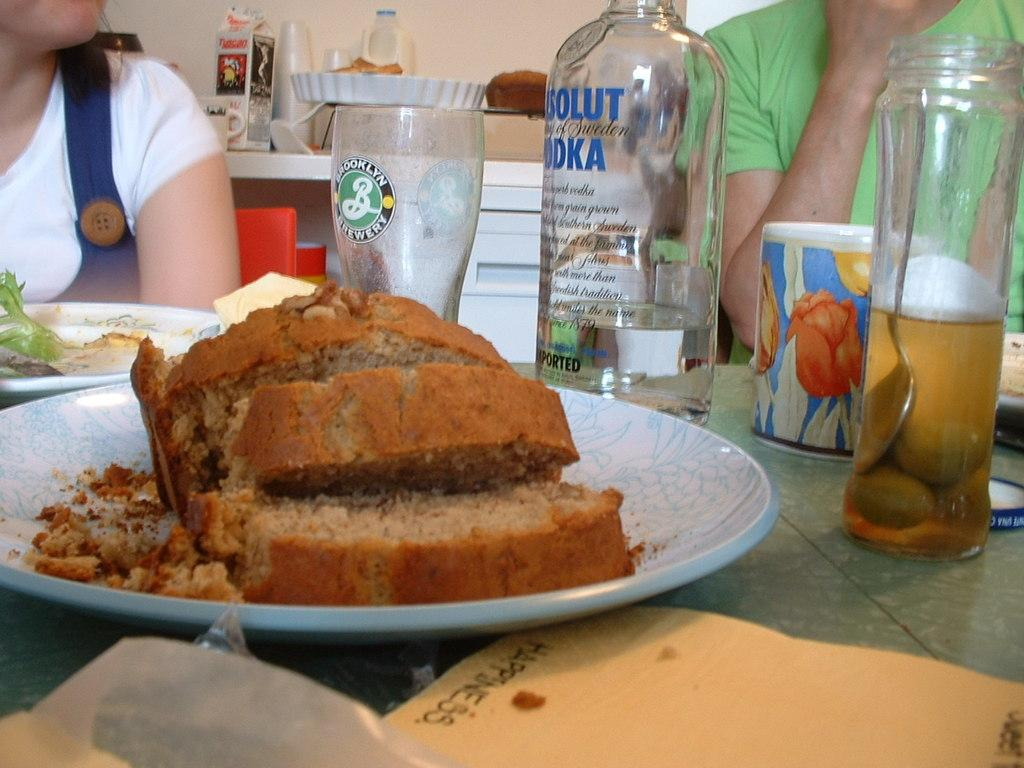How many people are in the image? There are two people in the image. What are the people wearing? The people are wearing clothes. What can be seen on the table in the image? There are plates, food, a glass, a bottle, and a paper on the table. What is the purpose of the box in the image? The purpose of the box in the image is not specified, but it is likely being used to hold or store something. What is the background of the image? There is a wall in the image, which serves as the background. What type of button is being used to drive the car in the image? There is no car or button present in the image; it features two people, a table, and various objects on the table. How many sheep are visible in the image? There are no sheep present in the image. 